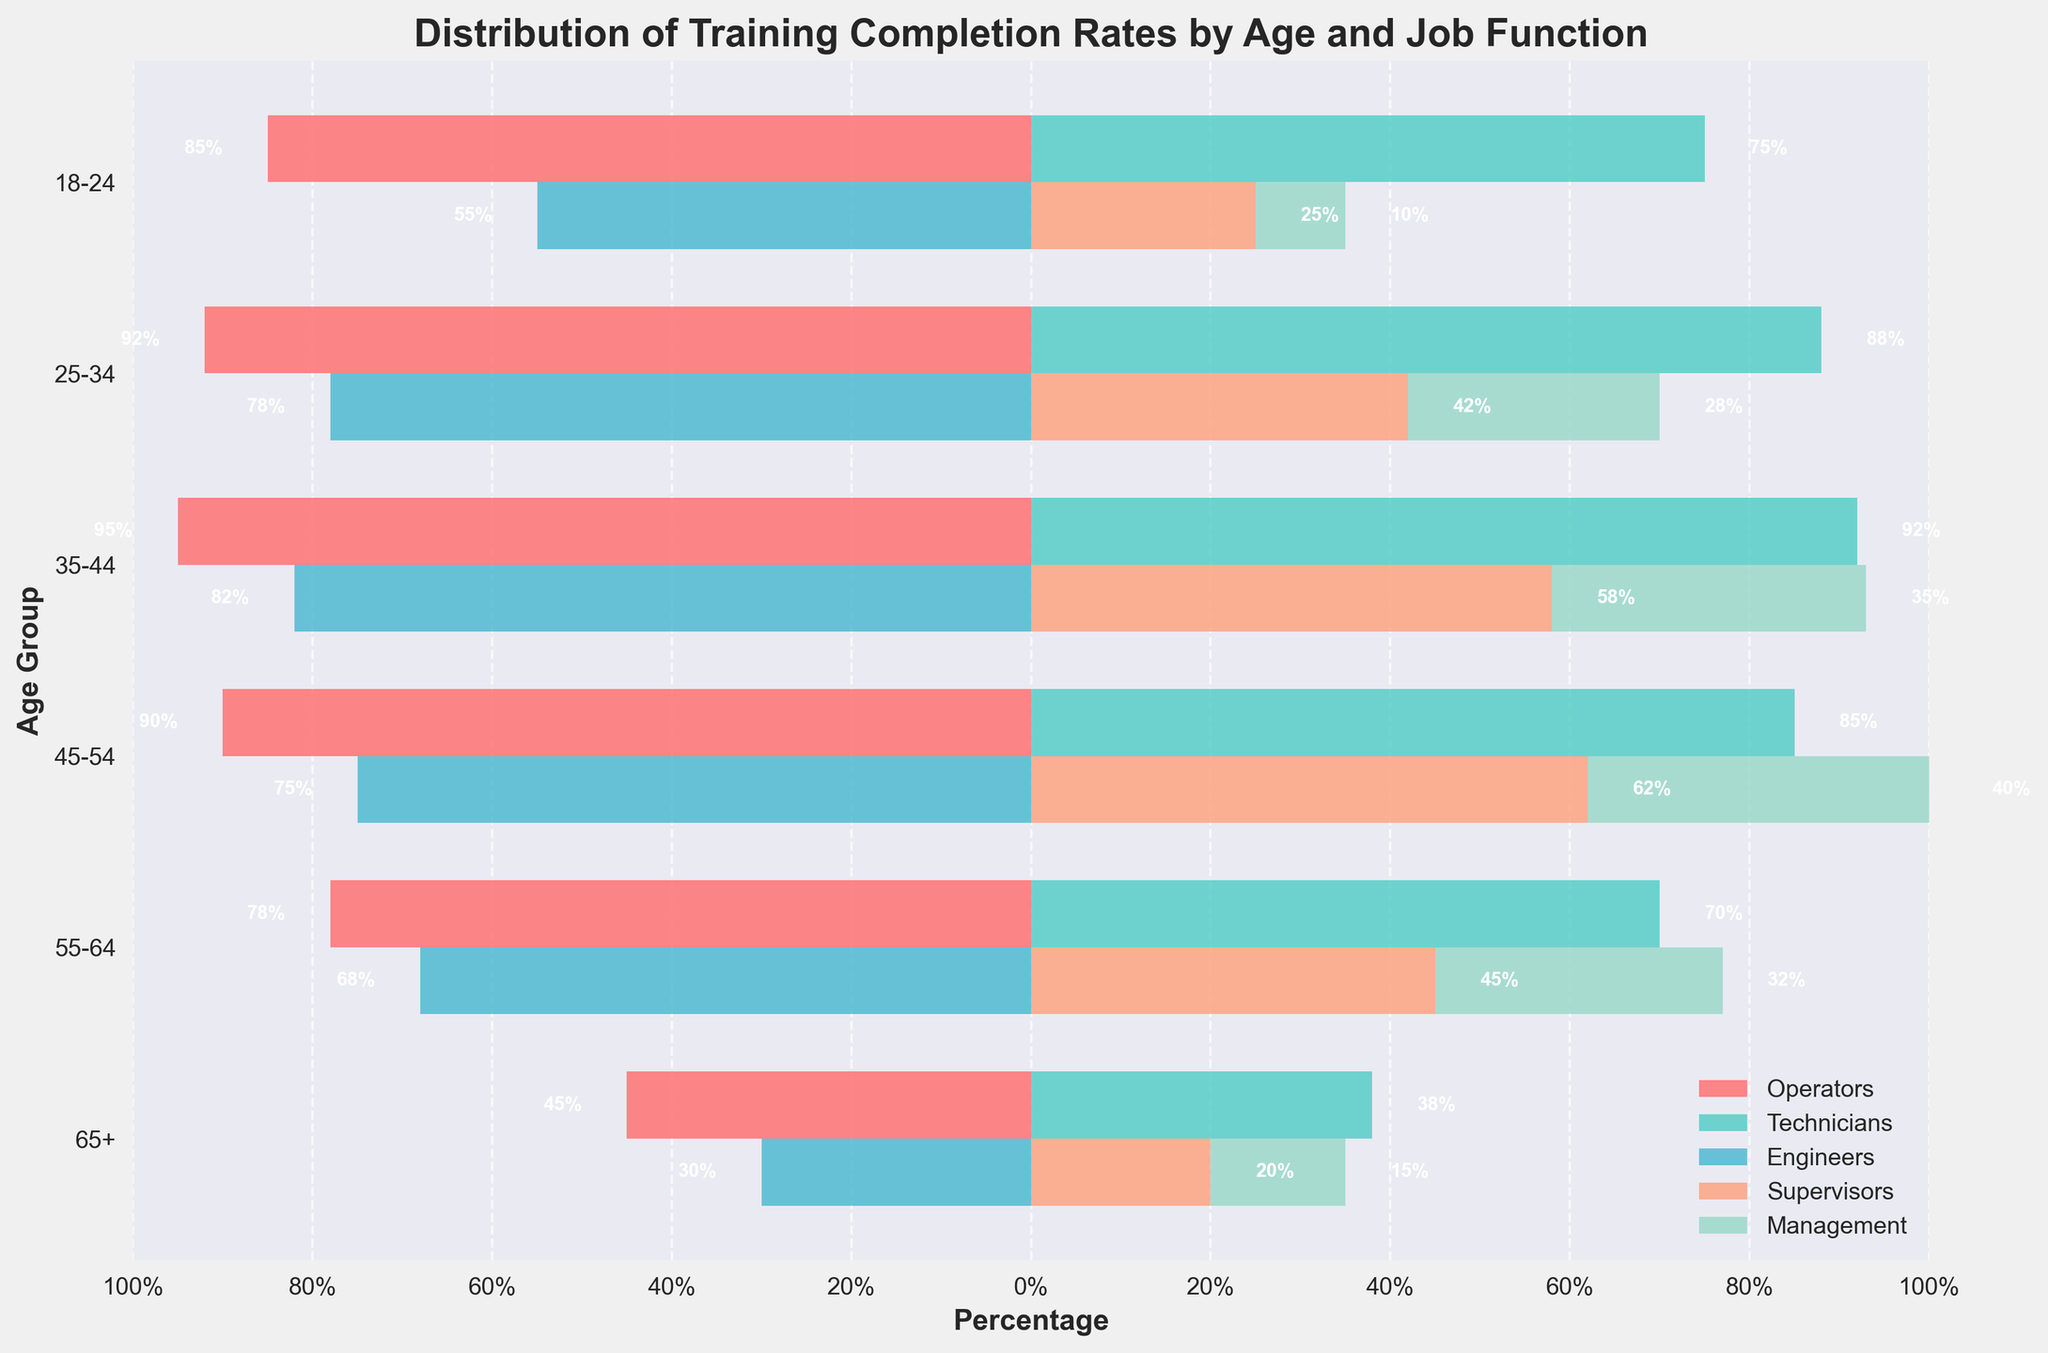what is the average percentage of completed training for technicians aged 25-34 and 35-44? Add the percentages for technicians in age groups 25-34 and 35-44 (88 + 92 = 180), and divide by 2.
Answer: 90% What age group has the highest percentage of management completing training? The bar for management is longest for the age group 45-54 (40%).
Answer: 45-54 Which job function shows a decreasing trend in training completion rates as age increases? By examining the bars across age groups, the length of the bars for Engineers consistently decreases, suggesting a decreasing trend.
Answer: Engineers What's the difference in training completion rates between operators aged 18-24 and 45-54? The percentages of operators for 18-24 and 45-54 are 85% and 90%, respectively. Subtracting these (90 - 85) gives a difference of 5%.
Answer: 5% In which age group is the disparity between supervisors and engineers the highest? By comparing the differences in each age group, the largest discrepancy is between supervisors and engineers aged 45-54, with values of 62% and 75%, respectively.
Answer: 45-54 